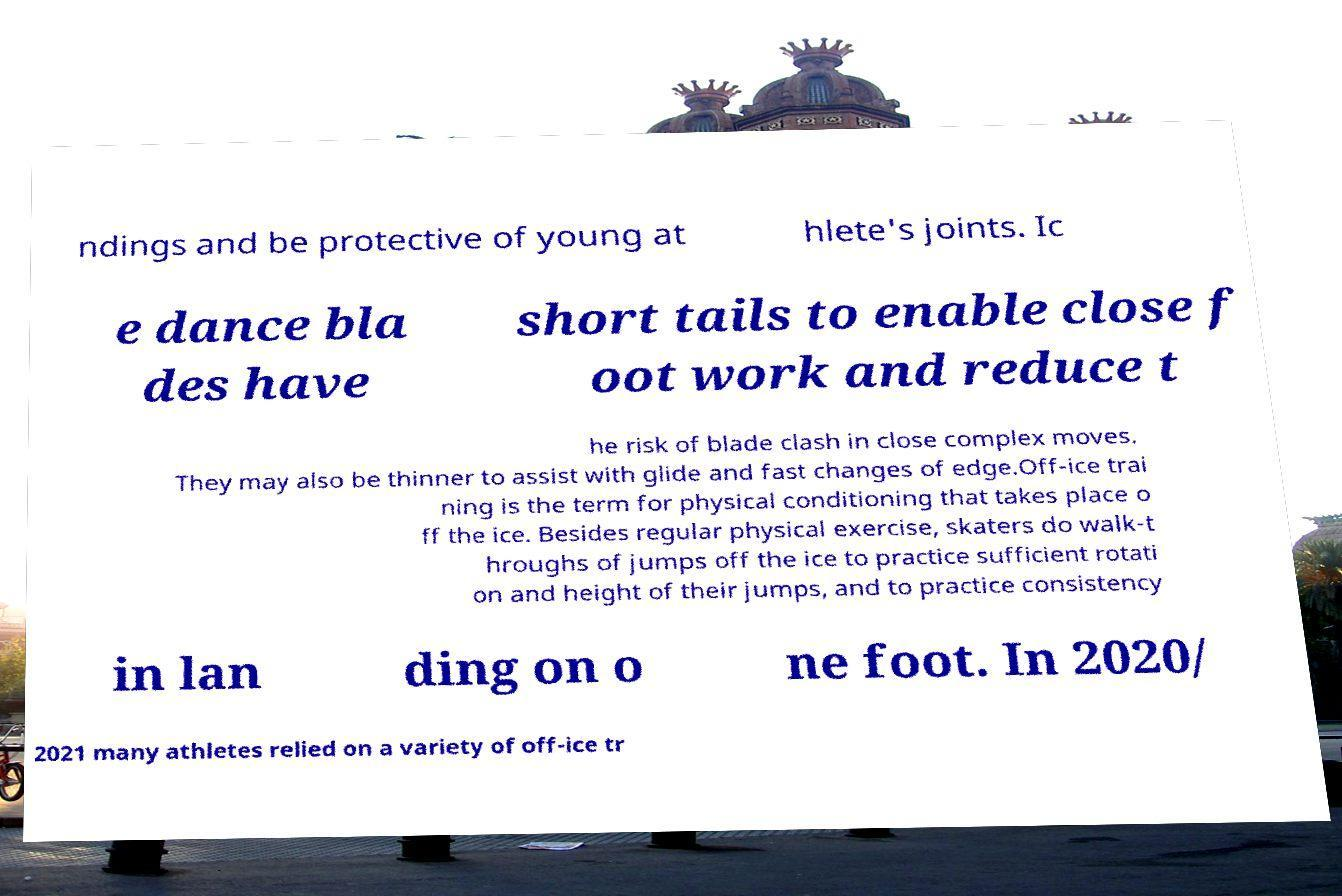Could you extract and type out the text from this image? ndings and be protective of young at hlete's joints. Ic e dance bla des have short tails to enable close f oot work and reduce t he risk of blade clash in close complex moves. They may also be thinner to assist with glide and fast changes of edge.Off-ice trai ning is the term for physical conditioning that takes place o ff the ice. Besides regular physical exercise, skaters do walk-t hroughs of jumps off the ice to practice sufficient rotati on and height of their jumps, and to practice consistency in lan ding on o ne foot. In 2020/ 2021 many athletes relied on a variety of off-ice tr 